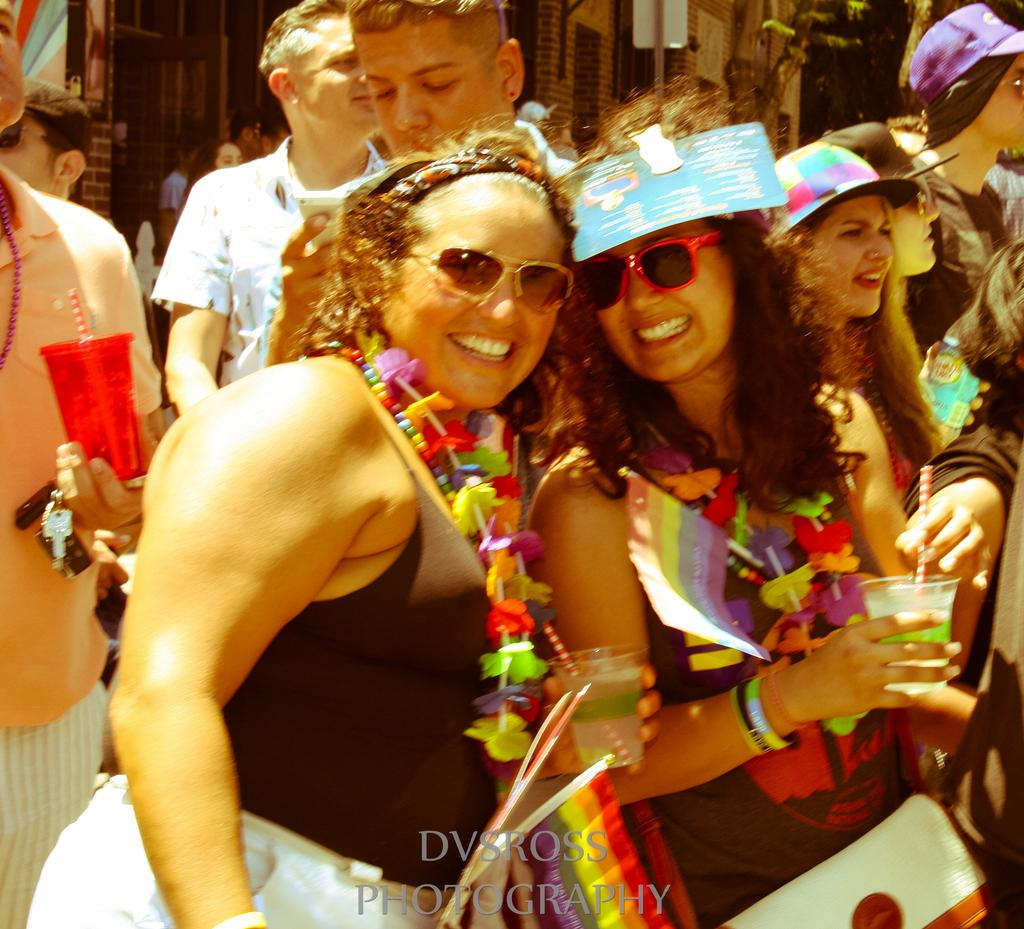How many people are in the image? There is a group of people in the image, but the exact number is not specified. What is one person holding in the image? One person is holding a glass in the image. Can you describe the flag in the image? The flag in the image has red, orange, yellow, and green colors. What can be seen in the background of the image? There are stalls visible in the background of the image. What type of bells can be heard ringing in the image? There are no bells present in the image, and therefore no sound can be heard. Is there a swing visible in the image? No, there is no swing visible in the image. 